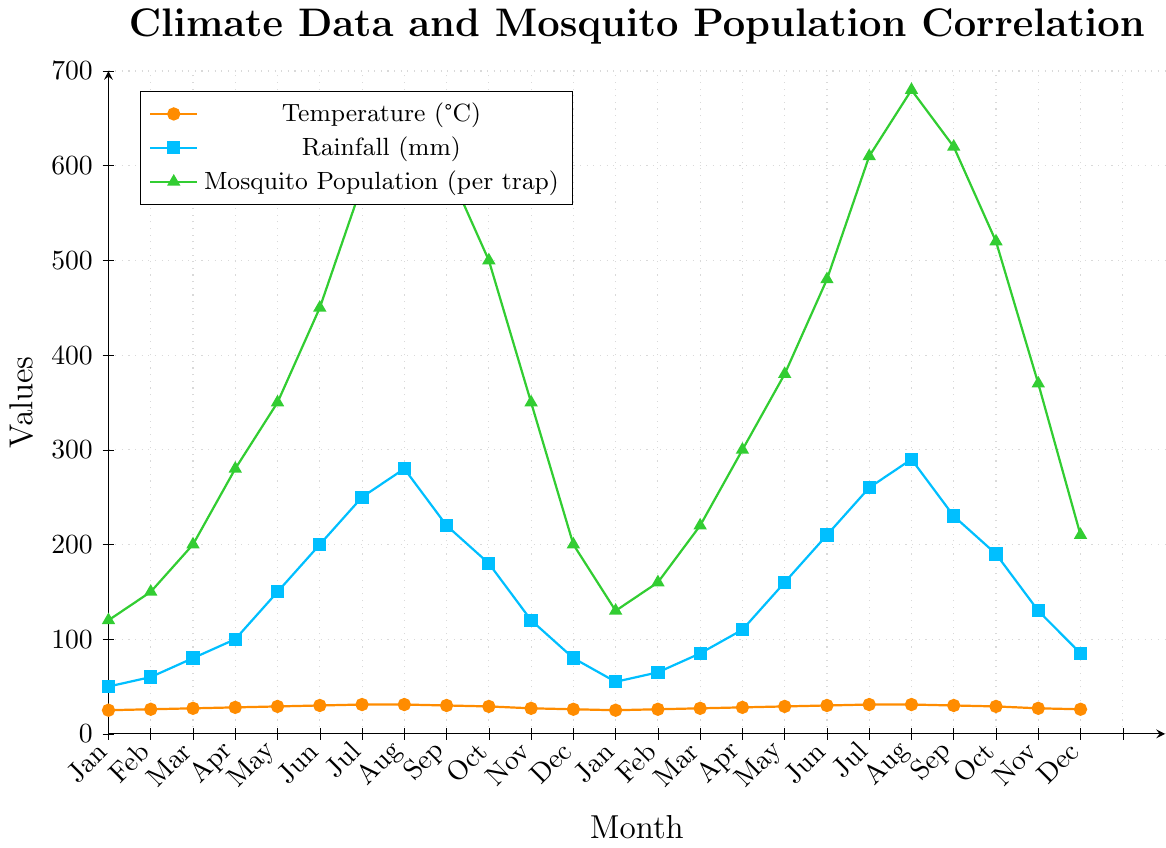What's the average mosquito population in the months with the highest temperature? The highest temperature, 31°C, occurs in July and August. The mosquito populations in July and August are 580, 650, 610, and 680. The average is (580 + 650 + 610 + 680) / 4 = 2520 / 4 = 630.
Answer: 630 Which month has the highest rainfall, and what is the mosquito population in that month? The month with the highest rainfall is August (290 mm). The mosquito population in that month is 650 and 680.
Answer: 650, 680 In which month is the difference between mosquito population and rainfall the largest? The differences between the mosquito population and rainfall for each month are calculated, and the largest value is identified. For example, for July with max. rainfall (290) and population (680). The difference is greatest in that month: 680 - 290 = 390. Repeat this for all months and compare.
Answer: August During which months do temperature and rainfall both reach their minimum values? The minimum temperature is 25°C, in January, and the minimum rainfall is 50 mm, also in January. Therefore, January is the month where both temperature and rainfall are at their minimum.
Answer: January What is the correlation trend you observe between rainfall and mosquito population? The mosquito population generally increases with increased rainfall. For instance, in June, both rainfall and mosquito numbers are rising significantly. Similar correlations occur in other months like July and August.
Answer: Positive correlation How does the mosquito population change from May to June each year? For the first year, the population increases from 350 in May to 450 in June. For the second year, the population increases from 380 in May to 480 in June. In both instances, it shows an upward trend.
Answer: Increases Compare the mosquito populations of both years in October, and indicate which year has a higher population. In October, the mosquito populations are 500 in the first year and 520 in the second year. Comparing these, the second year has a higher population in October.
Answer: Second year Which visual attribute indicates the mosquito population, and what color is used to represent it in the plot? The mosquito population is represented by the green line with triangles in the plot.
Answer: Green triangles During which months are the temperature and mosquito populations closest to each other? For example, in July and August, the differences between temperature (31°C) and mosquito population (580) in July and August, the differences are quite consistent, indicating close trends.
Answer: July and August 